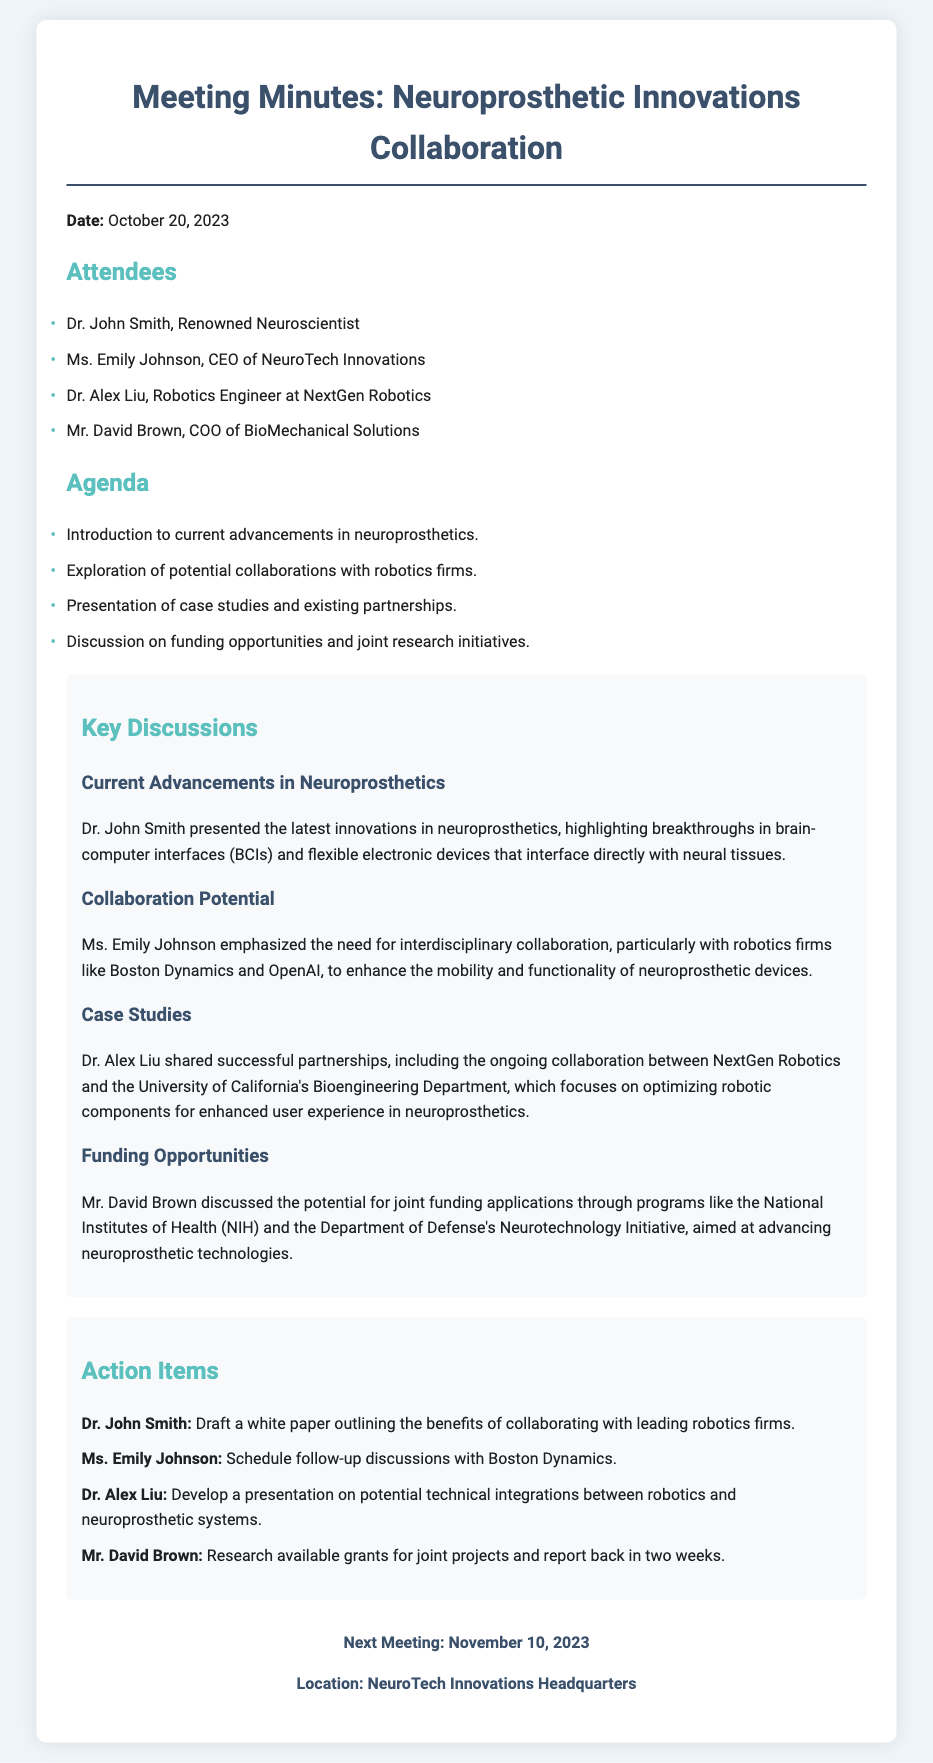What is the date of the meeting? The date of the meeting is stated at the beginning of the document.
Answer: October 20, 2023 Who is the COO of BioMechanical Solutions? The document lists attendees and their titles, providing specific names associated with each title.
Answer: Mr. David Brown Which robotics firm was mentioned alongside NeuroTech Innovations for collaboration? Ms. Emily Johnson emphasized a specific collaboration opportunity with a notable robotics firm in the discussion.
Answer: Boston Dynamics What funding programs were discussed in relation to neuroprosthetic technologies? Mr. David Brown highlighted specific funding programs available for joint applications in his discussion.
Answer: National Institutes of Health (NIH) What was Dr. John Smith's action item? The action items section outlines specific tasks assigned to attendees after discussions.
Answer: Draft a white paper outlining the benefits of collaborating with leading robotics firms What type of technology was highlighted in the advancements section? The key discussions section includes innovations that Dr. John Smith presented regarding neuroprosthetics.
Answer: Brain-computer interfaces (BCIs) How many attendees were present at the meeting? The attendees section lists names and titles, allowing for a count of the total participants.
Answer: Four What is the date of the next meeting? The next meeting details are provided at the end of the document, specifying the date for the follow-up meeting.
Answer: November 10, 2023 